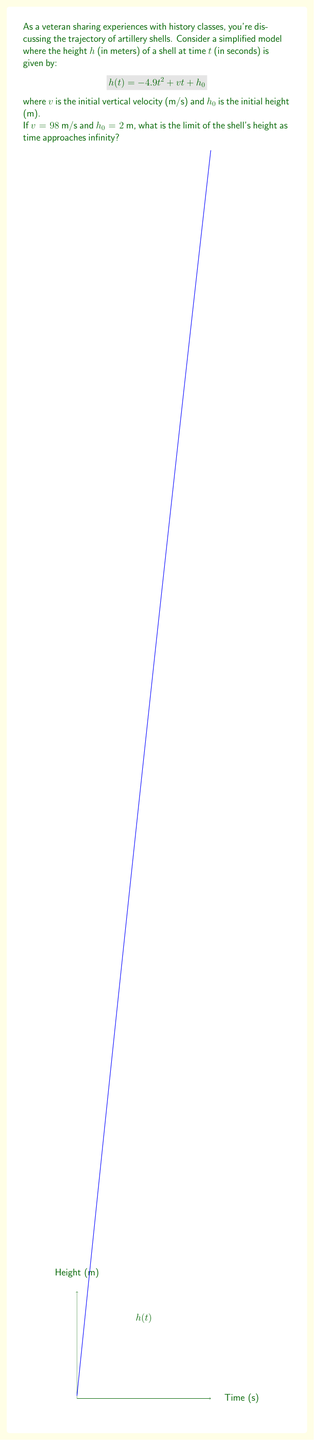Give your solution to this math problem. Let's approach this step-by-step:

1) We're given the function $h(t) = -4.9t^2 + vt + h_0$ with $v = 98$ and $h_0 = 2$.

2) Substituting these values:
   $h(t) = -4.9t^2 + 98t + 2$

3) To find the limit as $t$ approaches infinity, we need to consider the behavior of each term:

   - The $t^2$ term will grow much faster than the linear term.
   - The constant term becomes negligible.

4) As $t \to \infty$, the negative $t^2$ term will dominate:

   $\lim_{t \to \infty} (-4.9t^2 + 98t + 2) = \lim_{t \to \infty} -4.9t^2$

5) Any negative number multiplied by infinity approaches negative infinity.

6) Therefore, $\lim_{t \to \infty} h(t) = -\infty$

This makes physical sense: after reaching its peak, the shell will fall back to Earth and continue beyond (if we ignore air resistance and the Earth's surface).
Answer: $-\infty$ 